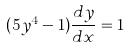<formula> <loc_0><loc_0><loc_500><loc_500>( 5 y ^ { 4 } - 1 ) \frac { d y } { d x } = 1</formula> 